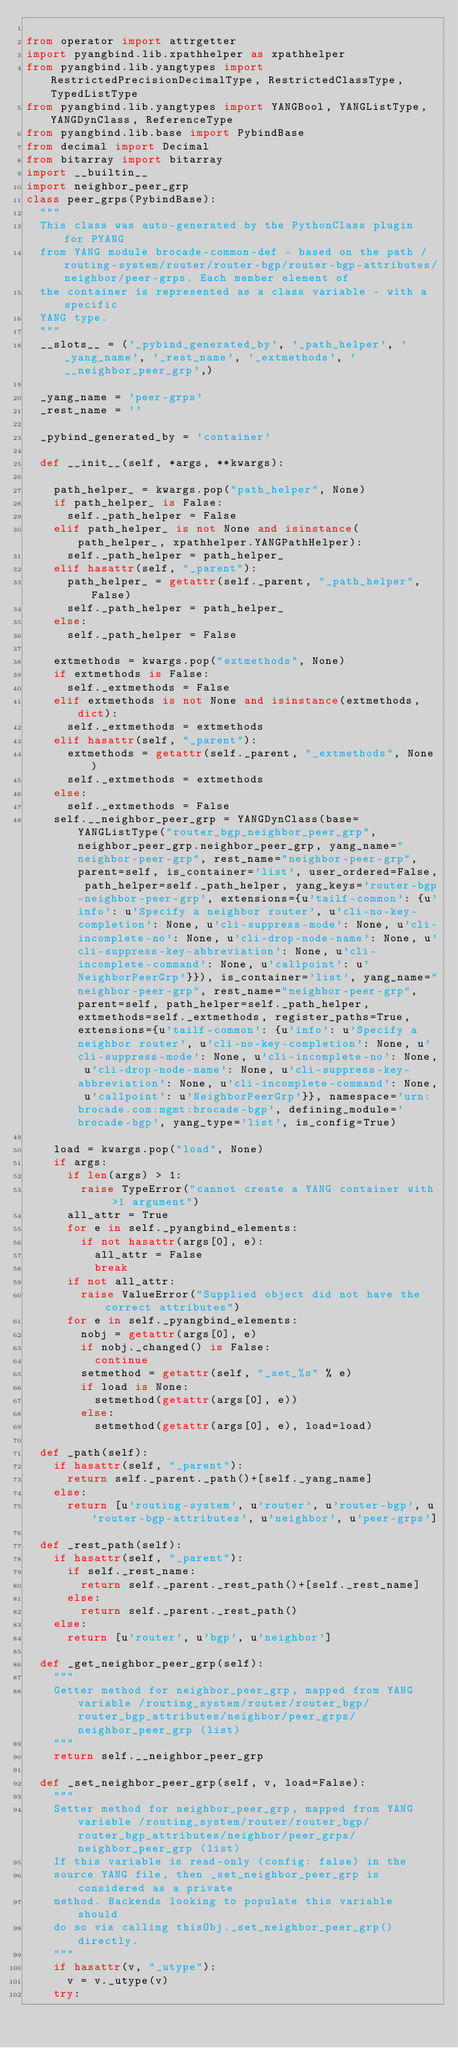<code> <loc_0><loc_0><loc_500><loc_500><_Python_>
from operator import attrgetter
import pyangbind.lib.xpathhelper as xpathhelper
from pyangbind.lib.yangtypes import RestrictedPrecisionDecimalType, RestrictedClassType, TypedListType
from pyangbind.lib.yangtypes import YANGBool, YANGListType, YANGDynClass, ReferenceType
from pyangbind.lib.base import PybindBase
from decimal import Decimal
from bitarray import bitarray
import __builtin__
import neighbor_peer_grp
class peer_grps(PybindBase):
  """
  This class was auto-generated by the PythonClass plugin for PYANG
  from YANG module brocade-common-def - based on the path /routing-system/router/router-bgp/router-bgp-attributes/neighbor/peer-grps. Each member element of
  the container is represented as a class variable - with a specific
  YANG type.
  """
  __slots__ = ('_pybind_generated_by', '_path_helper', '_yang_name', '_rest_name', '_extmethods', '__neighbor_peer_grp',)

  _yang_name = 'peer-grps'
  _rest_name = ''

  _pybind_generated_by = 'container'

  def __init__(self, *args, **kwargs):

    path_helper_ = kwargs.pop("path_helper", None)
    if path_helper_ is False:
      self._path_helper = False
    elif path_helper_ is not None and isinstance(path_helper_, xpathhelper.YANGPathHelper):
      self._path_helper = path_helper_
    elif hasattr(self, "_parent"):
      path_helper_ = getattr(self._parent, "_path_helper", False)
      self._path_helper = path_helper_
    else:
      self._path_helper = False

    extmethods = kwargs.pop("extmethods", None)
    if extmethods is False:
      self._extmethods = False
    elif extmethods is not None and isinstance(extmethods, dict):
      self._extmethods = extmethods
    elif hasattr(self, "_parent"):
      extmethods = getattr(self._parent, "_extmethods", None)
      self._extmethods = extmethods
    else:
      self._extmethods = False
    self.__neighbor_peer_grp = YANGDynClass(base=YANGListType("router_bgp_neighbor_peer_grp",neighbor_peer_grp.neighbor_peer_grp, yang_name="neighbor-peer-grp", rest_name="neighbor-peer-grp", parent=self, is_container='list', user_ordered=False, path_helper=self._path_helper, yang_keys='router-bgp-neighbor-peer-grp', extensions={u'tailf-common': {u'info': u'Specify a neighbor router', u'cli-no-key-completion': None, u'cli-suppress-mode': None, u'cli-incomplete-no': None, u'cli-drop-node-name': None, u'cli-suppress-key-abbreviation': None, u'cli-incomplete-command': None, u'callpoint': u'NeighborPeerGrp'}}), is_container='list', yang_name="neighbor-peer-grp", rest_name="neighbor-peer-grp", parent=self, path_helper=self._path_helper, extmethods=self._extmethods, register_paths=True, extensions={u'tailf-common': {u'info': u'Specify a neighbor router', u'cli-no-key-completion': None, u'cli-suppress-mode': None, u'cli-incomplete-no': None, u'cli-drop-node-name': None, u'cli-suppress-key-abbreviation': None, u'cli-incomplete-command': None, u'callpoint': u'NeighborPeerGrp'}}, namespace='urn:brocade.com:mgmt:brocade-bgp', defining_module='brocade-bgp', yang_type='list', is_config=True)

    load = kwargs.pop("load", None)
    if args:
      if len(args) > 1:
        raise TypeError("cannot create a YANG container with >1 argument")
      all_attr = True
      for e in self._pyangbind_elements:
        if not hasattr(args[0], e):
          all_attr = False
          break
      if not all_attr:
        raise ValueError("Supplied object did not have the correct attributes")
      for e in self._pyangbind_elements:
        nobj = getattr(args[0], e)
        if nobj._changed() is False:
          continue
        setmethod = getattr(self, "_set_%s" % e)
        if load is None:
          setmethod(getattr(args[0], e))
        else:
          setmethod(getattr(args[0], e), load=load)

  def _path(self):
    if hasattr(self, "_parent"):
      return self._parent._path()+[self._yang_name]
    else:
      return [u'routing-system', u'router', u'router-bgp', u'router-bgp-attributes', u'neighbor', u'peer-grps']

  def _rest_path(self):
    if hasattr(self, "_parent"):
      if self._rest_name:
        return self._parent._rest_path()+[self._rest_name]
      else:
        return self._parent._rest_path()
    else:
      return [u'router', u'bgp', u'neighbor']

  def _get_neighbor_peer_grp(self):
    """
    Getter method for neighbor_peer_grp, mapped from YANG variable /routing_system/router/router_bgp/router_bgp_attributes/neighbor/peer_grps/neighbor_peer_grp (list)
    """
    return self.__neighbor_peer_grp
      
  def _set_neighbor_peer_grp(self, v, load=False):
    """
    Setter method for neighbor_peer_grp, mapped from YANG variable /routing_system/router/router_bgp/router_bgp_attributes/neighbor/peer_grps/neighbor_peer_grp (list)
    If this variable is read-only (config: false) in the
    source YANG file, then _set_neighbor_peer_grp is considered as a private
    method. Backends looking to populate this variable should
    do so via calling thisObj._set_neighbor_peer_grp() directly.
    """
    if hasattr(v, "_utype"):
      v = v._utype(v)
    try:</code> 